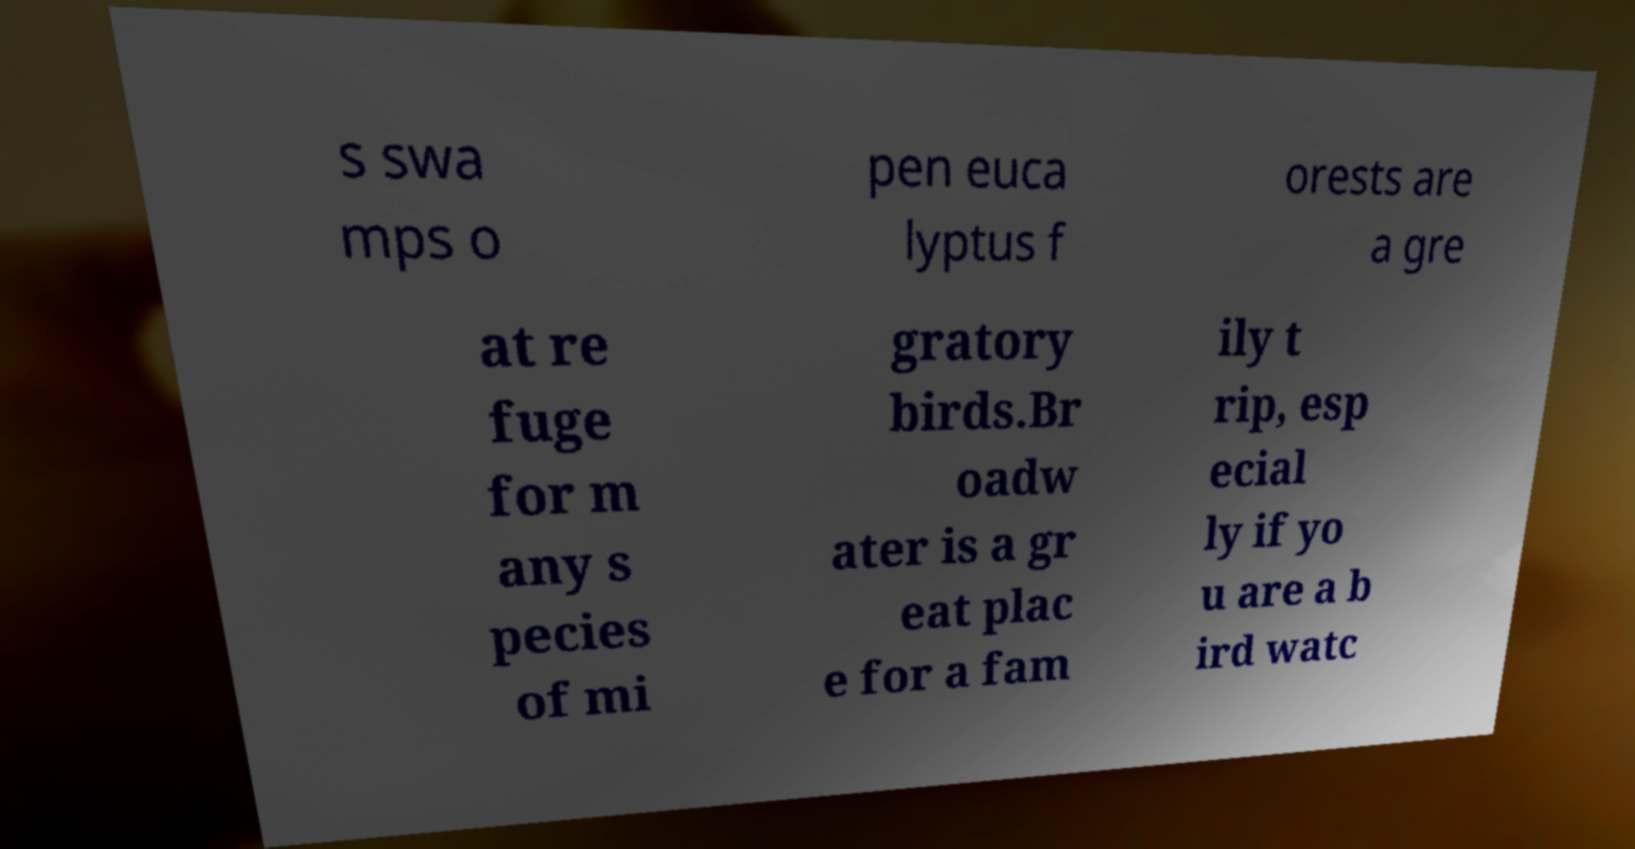Could you assist in decoding the text presented in this image and type it out clearly? s swa mps o pen euca lyptus f orests are a gre at re fuge for m any s pecies of mi gratory birds.Br oadw ater is a gr eat plac e for a fam ily t rip, esp ecial ly if yo u are a b ird watc 